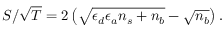Convert formula to latex. <formula><loc_0><loc_0><loc_500><loc_500>S / \sqrt { T } = 2 \left ( \sqrt { \epsilon _ { d } \epsilon _ { a } n _ { s } + n _ { b } } - \sqrt { n _ { b } } \right ) .</formula> 